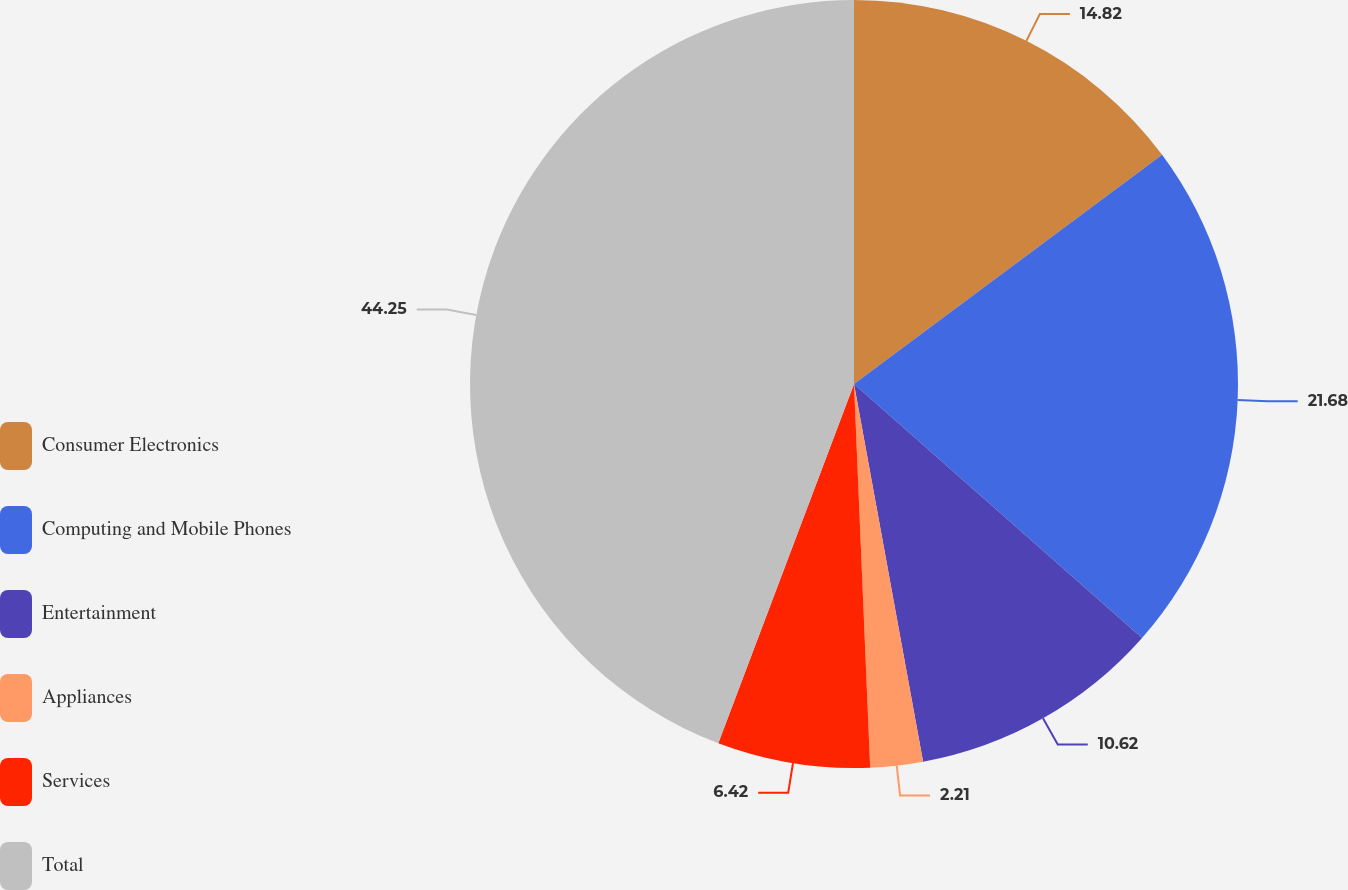Convert chart. <chart><loc_0><loc_0><loc_500><loc_500><pie_chart><fcel>Consumer Electronics<fcel>Computing and Mobile Phones<fcel>Entertainment<fcel>Appliances<fcel>Services<fcel>Total<nl><fcel>14.82%<fcel>21.68%<fcel>10.62%<fcel>2.21%<fcel>6.42%<fcel>44.25%<nl></chart> 